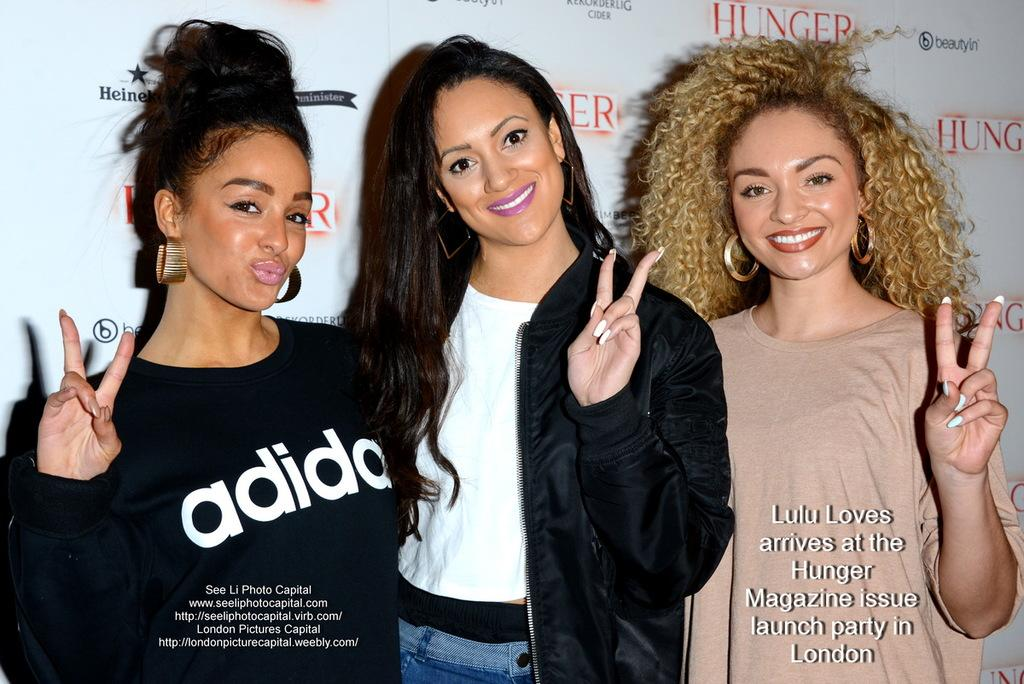How many women are present in the image? There are three women standing in the image. Can you describe the clothing of one of the women? One woman is wearing a black coat. What can be seen in the background of the image? There is a wall with text in the background of the image. What type of alarm is going off in the image? There is no alarm present in the image. What process are the women engaged in within the image? The image does not provide enough information to determine what process the women might be engaged in. 